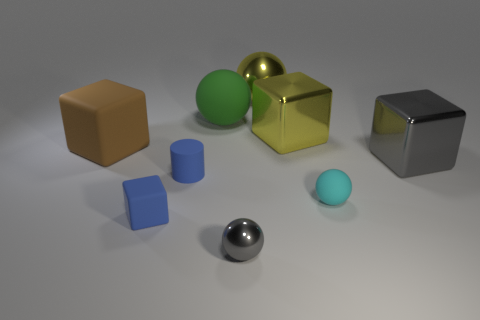What number of other things are there of the same color as the small matte cube?
Offer a very short reply. 1. There is a thing that is both in front of the large gray shiny block and behind the cyan thing; what is its color?
Give a very brief answer. Blue. There is a rubber ball that is to the left of the metallic sphere behind the gray sphere that is in front of the large rubber sphere; how big is it?
Provide a short and direct response. Large. What number of objects are either objects behind the matte cylinder or shiny balls that are in front of the brown object?
Offer a very short reply. 6. The tiny gray object has what shape?
Keep it short and to the point. Sphere. What number of other things are there of the same material as the large green sphere
Your response must be concise. 4. What is the size of the other cyan object that is the same shape as the small metal object?
Offer a terse response. Small. There is a small sphere that is right of the tiny sphere on the left side of the tiny cyan rubber object behind the small blue rubber block; what is it made of?
Your response must be concise. Rubber. Are there any tiny metallic balls?
Make the answer very short. Yes. There is a tiny rubber cylinder; is its color the same as the object that is in front of the blue block?
Your answer should be compact. No. 